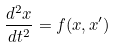Convert formula to latex. <formula><loc_0><loc_0><loc_500><loc_500>\frac { d ^ { 2 } x } { d t ^ { 2 } } = f ( x , x ^ { \prime } )</formula> 